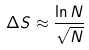<formula> <loc_0><loc_0><loc_500><loc_500>\Delta S \approx \frac { \ln N } { \sqrt { N } }</formula> 